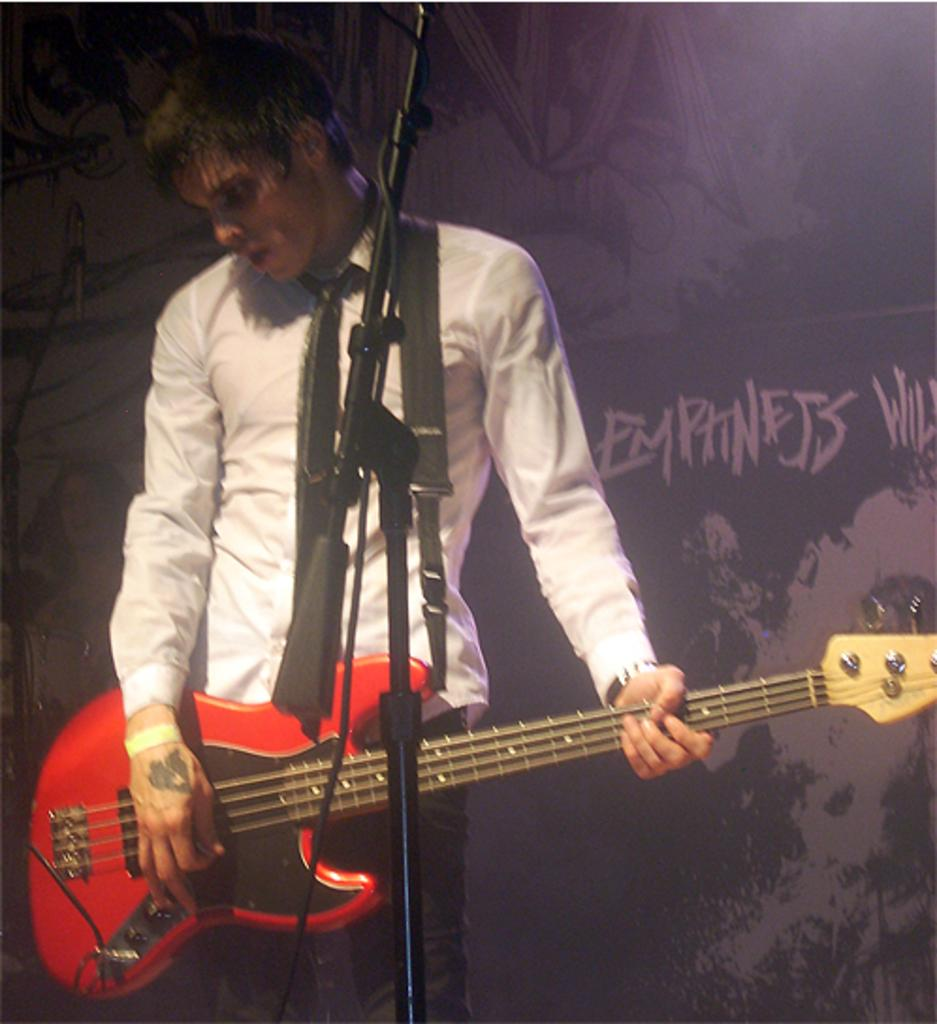What is the person in the image doing? The person is playing a guitar. What is the person wearing in the image? The person is wearing a white shirt and a black tie. What position is the person in while playing the guitar? The person is standing. Can you tell me how many friends are standing next to the person playing the guitar in the image? There is no information about friends or any other people in the image; it only shows a person playing a guitar. What is the condition of the person's knee in the image? There is no information about the person's knee in the image; it only shows the person playing a guitar. 